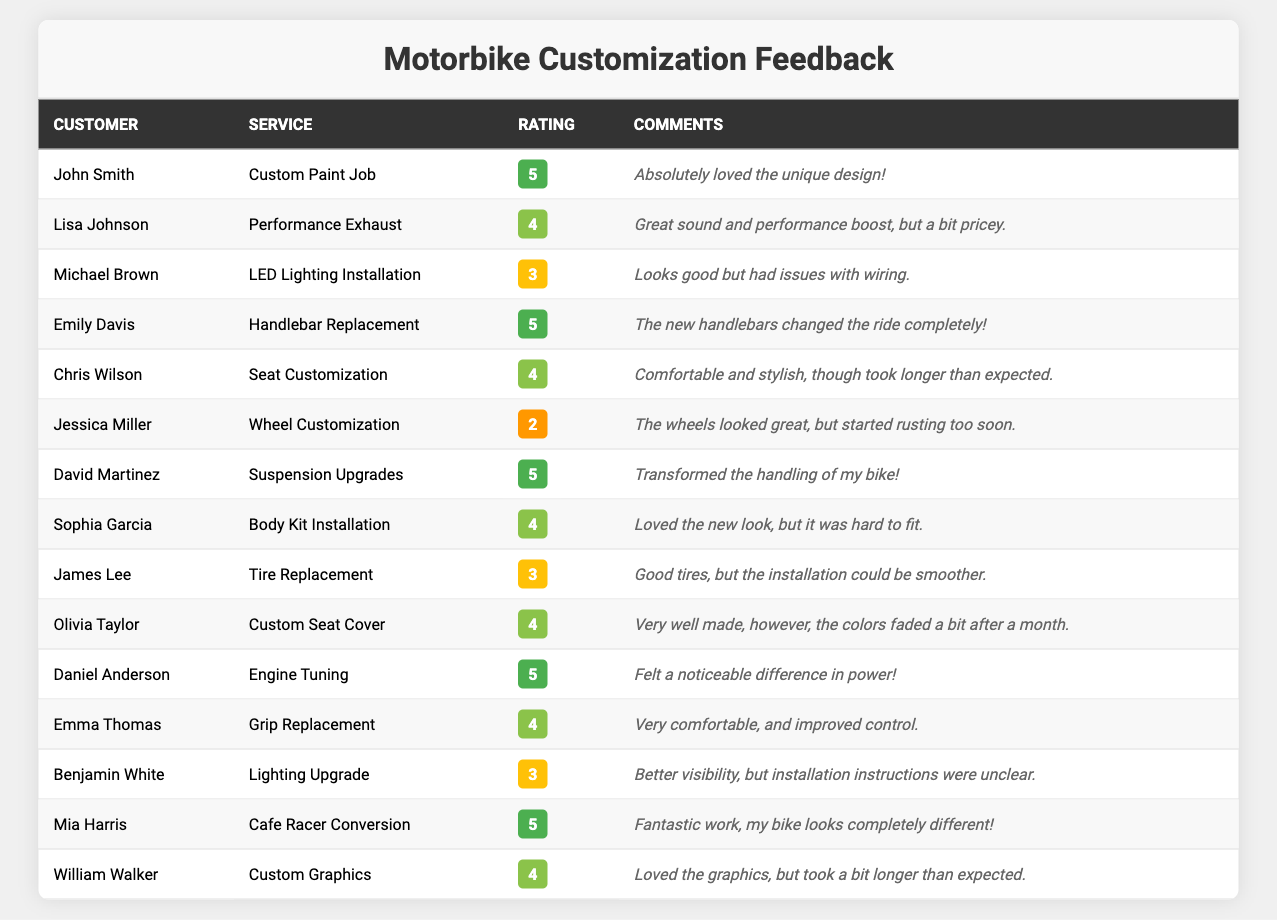What was the highest rating given to a service? The highest rating possible is 5. By examining the table, services that received a rating of 5 include "Custom Paint Job," "Handlebar Replacement," "Suspension Upgrades," "Engine Tuning," and "Cafe Racer Conversion."
Answer: 5 How many services received a rating of 4? By reviewing the table, the services with a rating of 4 are "Performance Exhaust," "Seat Customization," "Body Kit Installation," "Custom Seat Cover," "Grip Replacement," and "Custom Graphics." There are 6 such services.
Answer: 6 Did any customer give a rating of 2? Looking at the table, Jessica Miller provided a rating of 2 for "Wheel Customization." This means yes, there was a customer who rated a service as 2.
Answer: Yes What is the average rating across all services? To determine the average rating, we need to add all the ratings: (5 + 4 + 3 + 5 + 4 + 2 + 5 + 4 + 3 + 4 + 5 + 4 + 3 + 5 + 4) = 57. There are 15 services in total, so the average rating is 57/15 = 3.8.
Answer: 3.8 Which service received the lowest rating, and what was it? The lowest rating of 2 was given to "Wheel Customization" by Jessica Miller. Upon examining the ratings, this is the only service with this rating.
Answer: Wheel Customization, 2 How many services have ratings of 3 or lower? Looking at the table, there are 3 instances where the rating is either 2 or 3: "LED Lighting Installation" (3), "Wheel Customization" (2), and "Benjamin White's Lighting Upgrade" (3). Thus, there are 3 services with ratings of 3 or lower.
Answer: 3 What percentage of customers rated services with a score of 5? There are 5 instances of a score of 5 out of 15 total ratings. To find the percentage, (5/15) * 100 = 33.33%. Thus, approximately 33% of customers gave a rating of 5.
Answer: 33.33% Which customer gave a comment about a performance boost? By scanning through the comments, Lisa Johnson remarked that the "Performance Exhaust" improved sound and performance but was pricey. Moreover, Daniel Anderson noted that the "Engine Tuning" resulted in a noticeable difference in power.
Answer: Daniel Anderson How many customers provided feedback on the "Custom Paint Job"? From the table, only John Smith provided feedback on the "Custom Paint Job." Therefore, there is 1 customer who gave feedback on this service.
Answer: 1 Which service type had the most comments mentioning difficulty in the installation or fitting? Examining the comments, "Body Kit Installation" mentioned difficulty fitting, and "Tire Replacement" remarked that the installation could be smoother. Both these services highlight installation issues, suggesting there are at least 2 services with mentions of such difficulties.
Answer: Body Kit Installation, Tire Replacement Are there more services rated above 3 than those rated 3 or below? Services rated above 3 include: Custom Paint Job (5), Performance Exhaust (4), Handlebar Replacement (5), Seat Customization (4), Suspension Upgrades (5), Body Kit Installation (4), Custom Seat Cover (4), Engine Tuning (5), Grip Replacement (4), Cafe Racer Conversion (5), and Custom Graphics (4). This totals 11 services rated above 3, while there are only 3 rated 3 or below, confirming the assertion.
Answer: Yes 